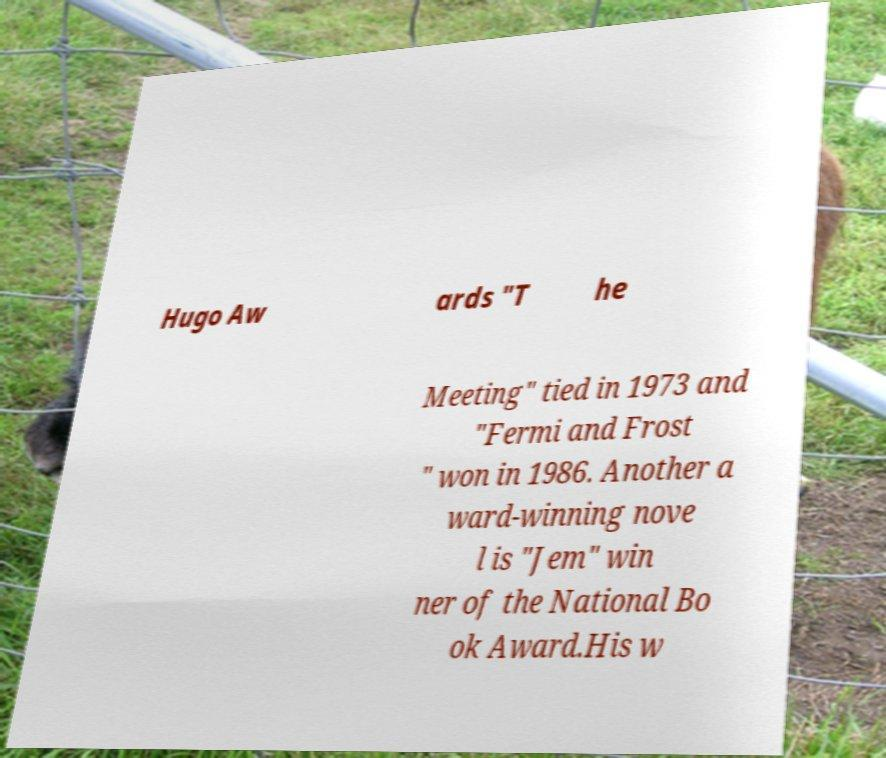Please identify and transcribe the text found in this image. Hugo Aw ards "T he Meeting" tied in 1973 and "Fermi and Frost " won in 1986. Another a ward-winning nove l is "Jem" win ner of the National Bo ok Award.His w 